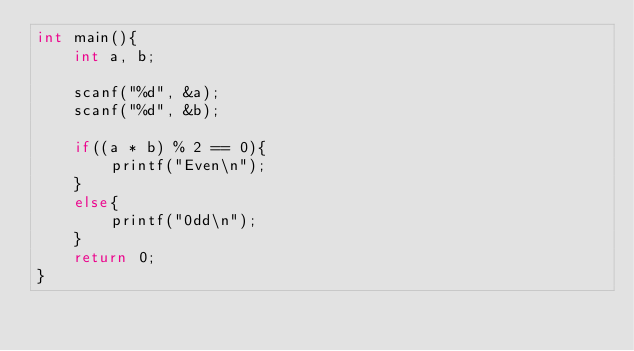<code> <loc_0><loc_0><loc_500><loc_500><_C_>int main(){
	int a, b;
    
    scanf("%d", &a);
    scanf("%d", &b);
    
    if((a * b) % 2 == 0){
    	printf("Even\n");
    }
    else{
    	printf("0dd\n");
    }
    return 0;
}</code> 